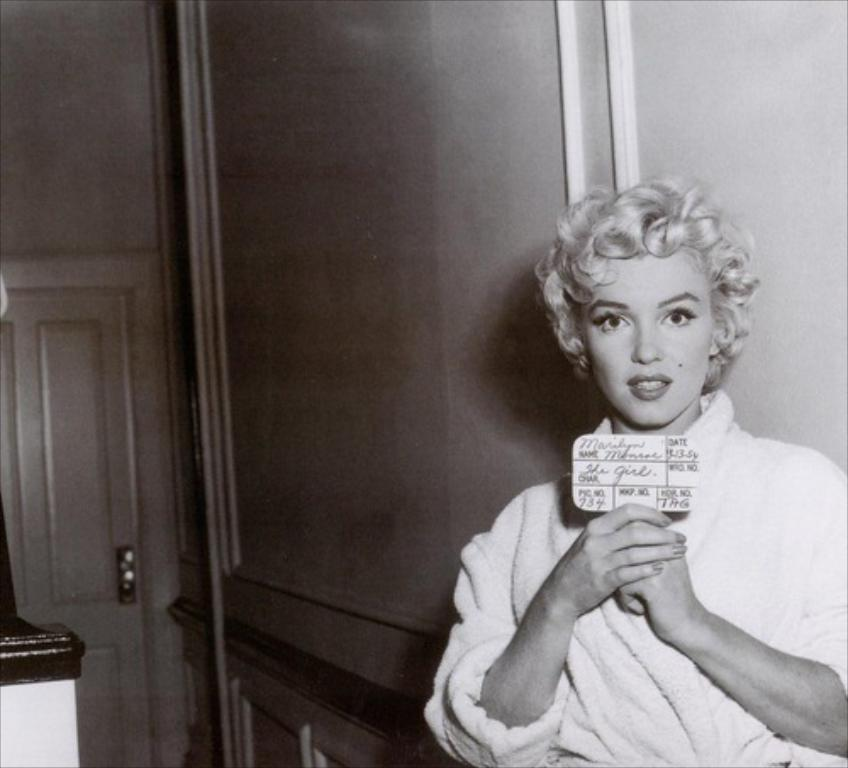What is the person in the image doing? The person is standing in the image and holding a board with text and numbers. Can you describe the board that the person is holding? The board has text and numbers on it. What can be seen in the background of the image? There is a wall in the background of the image, and it has a door and rods on it. How does the person in the image maintain a quiet environment while holding the board? The image does not provide information about the person maintaining a quiet environment, as the focus is on the person holding the board with text and numbers. 